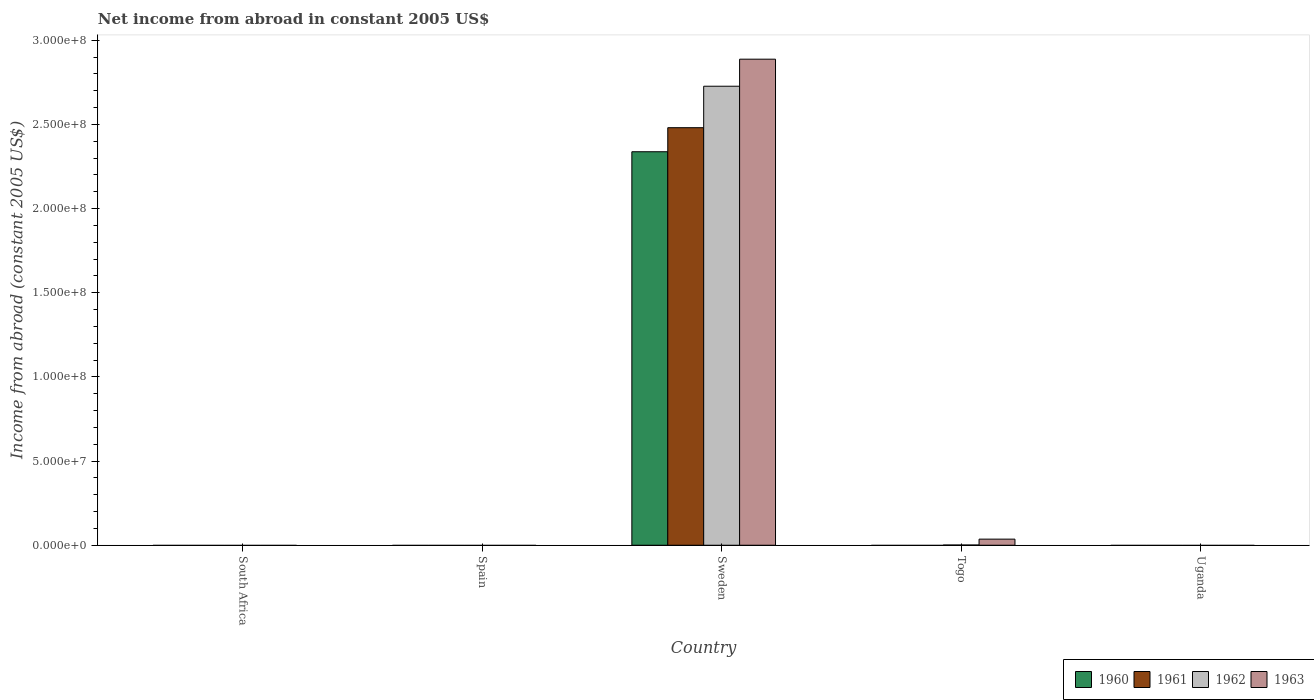Are the number of bars per tick equal to the number of legend labels?
Provide a succinct answer. No. How many bars are there on the 1st tick from the left?
Offer a very short reply. 0. What is the label of the 5th group of bars from the left?
Keep it short and to the point. Uganda. What is the net income from abroad in 1962 in Sweden?
Provide a succinct answer. 2.73e+08. Across all countries, what is the maximum net income from abroad in 1963?
Provide a short and direct response. 2.89e+08. In which country was the net income from abroad in 1963 maximum?
Offer a very short reply. Sweden. What is the total net income from abroad in 1962 in the graph?
Make the answer very short. 2.73e+08. What is the difference between the net income from abroad in 1961 in Sweden and the net income from abroad in 1962 in South Africa?
Keep it short and to the point. 2.48e+08. What is the average net income from abroad in 1963 per country?
Ensure brevity in your answer.  5.85e+07. What is the difference between the net income from abroad of/in 1962 and net income from abroad of/in 1963 in Sweden?
Offer a terse response. -1.61e+07. In how many countries, is the net income from abroad in 1963 greater than 100000000 US$?
Ensure brevity in your answer.  1. What is the difference between the highest and the lowest net income from abroad in 1960?
Your answer should be compact. 2.34e+08. In how many countries, is the net income from abroad in 1961 greater than the average net income from abroad in 1961 taken over all countries?
Provide a succinct answer. 1. Is it the case that in every country, the sum of the net income from abroad in 1960 and net income from abroad in 1961 is greater than the sum of net income from abroad in 1963 and net income from abroad in 1962?
Offer a terse response. No. Is it the case that in every country, the sum of the net income from abroad in 1960 and net income from abroad in 1963 is greater than the net income from abroad in 1962?
Your answer should be very brief. No. Does the graph contain any zero values?
Give a very brief answer. Yes. Where does the legend appear in the graph?
Your response must be concise. Bottom right. How are the legend labels stacked?
Ensure brevity in your answer.  Horizontal. What is the title of the graph?
Ensure brevity in your answer.  Net income from abroad in constant 2005 US$. Does "1969" appear as one of the legend labels in the graph?
Your response must be concise. No. What is the label or title of the Y-axis?
Your answer should be very brief. Income from abroad (constant 2005 US$). What is the Income from abroad (constant 2005 US$) in 1961 in South Africa?
Your response must be concise. 0. What is the Income from abroad (constant 2005 US$) in 1960 in Spain?
Offer a terse response. 0. What is the Income from abroad (constant 2005 US$) in 1962 in Spain?
Ensure brevity in your answer.  0. What is the Income from abroad (constant 2005 US$) in 1963 in Spain?
Your answer should be compact. 0. What is the Income from abroad (constant 2005 US$) in 1960 in Sweden?
Provide a succinct answer. 2.34e+08. What is the Income from abroad (constant 2005 US$) in 1961 in Sweden?
Give a very brief answer. 2.48e+08. What is the Income from abroad (constant 2005 US$) of 1962 in Sweden?
Provide a succinct answer. 2.73e+08. What is the Income from abroad (constant 2005 US$) of 1963 in Sweden?
Your answer should be compact. 2.89e+08. What is the Income from abroad (constant 2005 US$) of 1961 in Togo?
Your response must be concise. 0. What is the Income from abroad (constant 2005 US$) in 1962 in Togo?
Your answer should be compact. 1.22e+05. What is the Income from abroad (constant 2005 US$) in 1963 in Togo?
Make the answer very short. 3.62e+06. What is the Income from abroad (constant 2005 US$) in 1961 in Uganda?
Offer a terse response. 0. What is the Income from abroad (constant 2005 US$) in 1963 in Uganda?
Offer a very short reply. 0. Across all countries, what is the maximum Income from abroad (constant 2005 US$) in 1960?
Offer a very short reply. 2.34e+08. Across all countries, what is the maximum Income from abroad (constant 2005 US$) in 1961?
Offer a very short reply. 2.48e+08. Across all countries, what is the maximum Income from abroad (constant 2005 US$) of 1962?
Make the answer very short. 2.73e+08. Across all countries, what is the maximum Income from abroad (constant 2005 US$) of 1963?
Offer a very short reply. 2.89e+08. Across all countries, what is the minimum Income from abroad (constant 2005 US$) of 1960?
Provide a succinct answer. 0. Across all countries, what is the minimum Income from abroad (constant 2005 US$) in 1963?
Make the answer very short. 0. What is the total Income from abroad (constant 2005 US$) in 1960 in the graph?
Offer a terse response. 2.34e+08. What is the total Income from abroad (constant 2005 US$) of 1961 in the graph?
Ensure brevity in your answer.  2.48e+08. What is the total Income from abroad (constant 2005 US$) of 1962 in the graph?
Keep it short and to the point. 2.73e+08. What is the total Income from abroad (constant 2005 US$) in 1963 in the graph?
Your answer should be very brief. 2.92e+08. What is the difference between the Income from abroad (constant 2005 US$) of 1962 in Sweden and that in Togo?
Offer a terse response. 2.73e+08. What is the difference between the Income from abroad (constant 2005 US$) of 1963 in Sweden and that in Togo?
Provide a succinct answer. 2.85e+08. What is the difference between the Income from abroad (constant 2005 US$) in 1960 in Sweden and the Income from abroad (constant 2005 US$) in 1962 in Togo?
Offer a terse response. 2.34e+08. What is the difference between the Income from abroad (constant 2005 US$) in 1960 in Sweden and the Income from abroad (constant 2005 US$) in 1963 in Togo?
Your answer should be very brief. 2.30e+08. What is the difference between the Income from abroad (constant 2005 US$) of 1961 in Sweden and the Income from abroad (constant 2005 US$) of 1962 in Togo?
Keep it short and to the point. 2.48e+08. What is the difference between the Income from abroad (constant 2005 US$) of 1961 in Sweden and the Income from abroad (constant 2005 US$) of 1963 in Togo?
Provide a short and direct response. 2.44e+08. What is the difference between the Income from abroad (constant 2005 US$) in 1962 in Sweden and the Income from abroad (constant 2005 US$) in 1963 in Togo?
Keep it short and to the point. 2.69e+08. What is the average Income from abroad (constant 2005 US$) of 1960 per country?
Give a very brief answer. 4.68e+07. What is the average Income from abroad (constant 2005 US$) of 1961 per country?
Keep it short and to the point. 4.96e+07. What is the average Income from abroad (constant 2005 US$) in 1962 per country?
Offer a terse response. 5.46e+07. What is the average Income from abroad (constant 2005 US$) in 1963 per country?
Your answer should be compact. 5.85e+07. What is the difference between the Income from abroad (constant 2005 US$) in 1960 and Income from abroad (constant 2005 US$) in 1961 in Sweden?
Provide a short and direct response. -1.43e+07. What is the difference between the Income from abroad (constant 2005 US$) of 1960 and Income from abroad (constant 2005 US$) of 1962 in Sweden?
Offer a terse response. -3.89e+07. What is the difference between the Income from abroad (constant 2005 US$) of 1960 and Income from abroad (constant 2005 US$) of 1963 in Sweden?
Your response must be concise. -5.50e+07. What is the difference between the Income from abroad (constant 2005 US$) in 1961 and Income from abroad (constant 2005 US$) in 1962 in Sweden?
Offer a very short reply. -2.46e+07. What is the difference between the Income from abroad (constant 2005 US$) in 1961 and Income from abroad (constant 2005 US$) in 1963 in Sweden?
Provide a short and direct response. -4.07e+07. What is the difference between the Income from abroad (constant 2005 US$) in 1962 and Income from abroad (constant 2005 US$) in 1963 in Sweden?
Provide a succinct answer. -1.61e+07. What is the difference between the Income from abroad (constant 2005 US$) in 1962 and Income from abroad (constant 2005 US$) in 1963 in Togo?
Provide a succinct answer. -3.50e+06. What is the ratio of the Income from abroad (constant 2005 US$) of 1962 in Sweden to that in Togo?
Your answer should be very brief. 2230.99. What is the ratio of the Income from abroad (constant 2005 US$) of 1963 in Sweden to that in Togo?
Your answer should be compact. 79.67. What is the difference between the highest and the lowest Income from abroad (constant 2005 US$) of 1960?
Offer a very short reply. 2.34e+08. What is the difference between the highest and the lowest Income from abroad (constant 2005 US$) in 1961?
Offer a terse response. 2.48e+08. What is the difference between the highest and the lowest Income from abroad (constant 2005 US$) of 1962?
Offer a very short reply. 2.73e+08. What is the difference between the highest and the lowest Income from abroad (constant 2005 US$) of 1963?
Ensure brevity in your answer.  2.89e+08. 